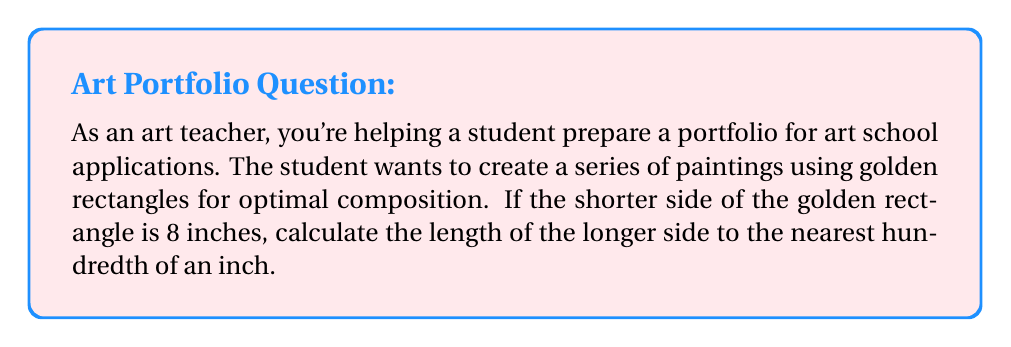Could you help me with this problem? To solve this problem, we need to understand the properties of a golden rectangle and use the golden ratio. Let's break it down step-by-step:

1) The golden ratio, often denoted by the Greek letter phi (φ), is approximately equal to 1.618033988749895.

2) In a golden rectangle, the ratio of the longer side to the shorter side is equal to the golden ratio.

3) Let's denote the shorter side as $a$ and the longer side as $b$. We're given that $a = 8$ inches.

4) The golden ratio property can be expressed mathematically as:

   $$\frac{b}{a} = φ$$

5) Substituting the known values:

   $$\frac{b}{8} = 1.618033988749895$$

6) To find $b$, we multiply both sides by 8:

   $$b = 8 * 1.618033988749895$$

7) Calculating this:

   $$b = 12.94427191$$

8) Rounding to the nearest hundredth:

   $$b ≈ 12.94$$ inches

Therefore, the longer side of the golden rectangle should be approximately 12.94 inches.
Answer: 12.94 inches 